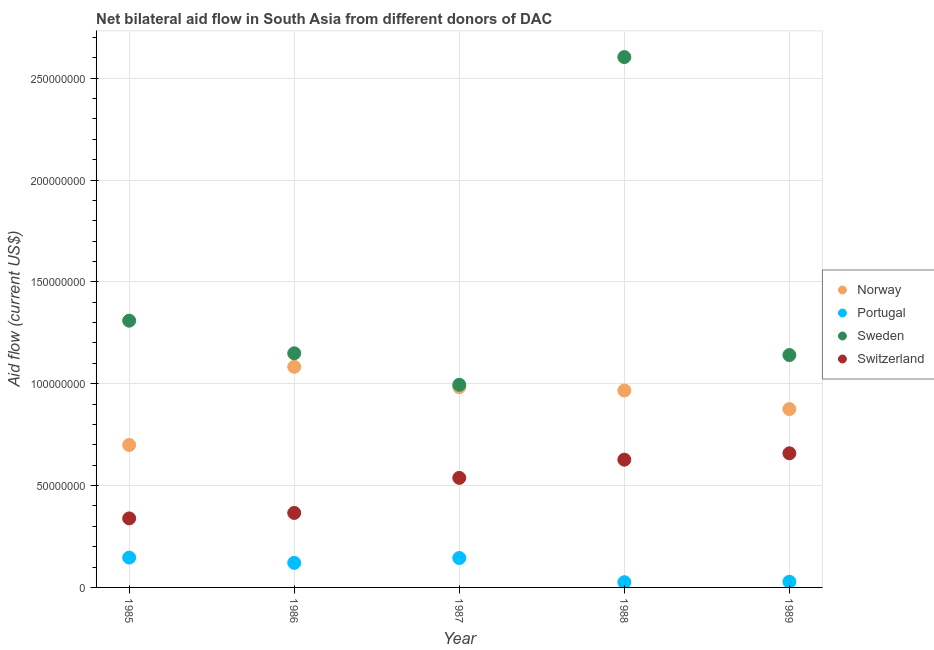Is the number of dotlines equal to the number of legend labels?
Your answer should be very brief. Yes. What is the amount of aid given by norway in 1985?
Keep it short and to the point. 6.99e+07. Across all years, what is the maximum amount of aid given by sweden?
Ensure brevity in your answer.  2.60e+08. Across all years, what is the minimum amount of aid given by sweden?
Your answer should be compact. 9.95e+07. In which year was the amount of aid given by portugal maximum?
Provide a succinct answer. 1985. What is the total amount of aid given by portugal in the graph?
Keep it short and to the point. 4.65e+07. What is the difference between the amount of aid given by sweden in 1988 and that in 1989?
Ensure brevity in your answer.  1.46e+08. What is the difference between the amount of aid given by portugal in 1989 and the amount of aid given by norway in 1987?
Keep it short and to the point. -9.55e+07. What is the average amount of aid given by switzerland per year?
Your answer should be very brief. 5.06e+07. In the year 1989, what is the difference between the amount of aid given by switzerland and amount of aid given by norway?
Offer a very short reply. -2.17e+07. In how many years, is the amount of aid given by portugal greater than 20000000 US$?
Make the answer very short. 0. What is the ratio of the amount of aid given by switzerland in 1986 to that in 1988?
Offer a terse response. 0.58. Is the amount of aid given by switzerland in 1985 less than that in 1986?
Give a very brief answer. Yes. Is the difference between the amount of aid given by norway in 1985 and 1988 greater than the difference between the amount of aid given by portugal in 1985 and 1988?
Your answer should be compact. No. What is the difference between the highest and the second highest amount of aid given by switzerland?
Offer a very short reply. 3.14e+06. What is the difference between the highest and the lowest amount of aid given by switzerland?
Keep it short and to the point. 3.20e+07. In how many years, is the amount of aid given by portugal greater than the average amount of aid given by portugal taken over all years?
Your response must be concise. 3. Is it the case that in every year, the sum of the amount of aid given by norway and amount of aid given by portugal is greater than the amount of aid given by sweden?
Provide a short and direct response. No. Does the amount of aid given by sweden monotonically increase over the years?
Keep it short and to the point. No. Is the amount of aid given by norway strictly less than the amount of aid given by sweden over the years?
Keep it short and to the point. Yes. How many dotlines are there?
Provide a succinct answer. 4. How many years are there in the graph?
Keep it short and to the point. 5. What is the difference between two consecutive major ticks on the Y-axis?
Your response must be concise. 5.00e+07. How many legend labels are there?
Keep it short and to the point. 4. What is the title of the graph?
Offer a very short reply. Net bilateral aid flow in South Asia from different donors of DAC. What is the label or title of the X-axis?
Offer a very short reply. Year. What is the label or title of the Y-axis?
Keep it short and to the point. Aid flow (current US$). What is the Aid flow (current US$) of Norway in 1985?
Ensure brevity in your answer.  6.99e+07. What is the Aid flow (current US$) in Portugal in 1985?
Give a very brief answer. 1.46e+07. What is the Aid flow (current US$) of Sweden in 1985?
Provide a succinct answer. 1.31e+08. What is the Aid flow (current US$) in Switzerland in 1985?
Your answer should be very brief. 3.39e+07. What is the Aid flow (current US$) of Norway in 1986?
Your answer should be very brief. 1.08e+08. What is the Aid flow (current US$) of Portugal in 1986?
Ensure brevity in your answer.  1.21e+07. What is the Aid flow (current US$) in Sweden in 1986?
Make the answer very short. 1.15e+08. What is the Aid flow (current US$) of Switzerland in 1986?
Keep it short and to the point. 3.66e+07. What is the Aid flow (current US$) in Norway in 1987?
Make the answer very short. 9.83e+07. What is the Aid flow (current US$) in Portugal in 1987?
Offer a terse response. 1.44e+07. What is the Aid flow (current US$) in Sweden in 1987?
Keep it short and to the point. 9.95e+07. What is the Aid flow (current US$) of Switzerland in 1987?
Your answer should be very brief. 5.38e+07. What is the Aid flow (current US$) of Norway in 1988?
Your response must be concise. 9.67e+07. What is the Aid flow (current US$) in Portugal in 1988?
Your answer should be very brief. 2.56e+06. What is the Aid flow (current US$) in Sweden in 1988?
Provide a succinct answer. 2.60e+08. What is the Aid flow (current US$) of Switzerland in 1988?
Your answer should be compact. 6.27e+07. What is the Aid flow (current US$) in Norway in 1989?
Make the answer very short. 8.76e+07. What is the Aid flow (current US$) in Portugal in 1989?
Ensure brevity in your answer.  2.79e+06. What is the Aid flow (current US$) in Sweden in 1989?
Give a very brief answer. 1.14e+08. What is the Aid flow (current US$) in Switzerland in 1989?
Make the answer very short. 6.58e+07. Across all years, what is the maximum Aid flow (current US$) in Norway?
Your answer should be compact. 1.08e+08. Across all years, what is the maximum Aid flow (current US$) in Portugal?
Your answer should be very brief. 1.46e+07. Across all years, what is the maximum Aid flow (current US$) of Sweden?
Ensure brevity in your answer.  2.60e+08. Across all years, what is the maximum Aid flow (current US$) of Switzerland?
Provide a succinct answer. 6.58e+07. Across all years, what is the minimum Aid flow (current US$) in Norway?
Keep it short and to the point. 6.99e+07. Across all years, what is the minimum Aid flow (current US$) in Portugal?
Provide a short and direct response. 2.56e+06. Across all years, what is the minimum Aid flow (current US$) in Sweden?
Offer a very short reply. 9.95e+07. Across all years, what is the minimum Aid flow (current US$) of Switzerland?
Ensure brevity in your answer.  3.39e+07. What is the total Aid flow (current US$) in Norway in the graph?
Offer a very short reply. 4.61e+08. What is the total Aid flow (current US$) of Portugal in the graph?
Provide a short and direct response. 4.65e+07. What is the total Aid flow (current US$) of Sweden in the graph?
Your response must be concise. 7.20e+08. What is the total Aid flow (current US$) in Switzerland in the graph?
Keep it short and to the point. 2.53e+08. What is the difference between the Aid flow (current US$) of Norway in 1985 and that in 1986?
Offer a terse response. -3.84e+07. What is the difference between the Aid flow (current US$) in Portugal in 1985 and that in 1986?
Your answer should be very brief. 2.59e+06. What is the difference between the Aid flow (current US$) in Sweden in 1985 and that in 1986?
Keep it short and to the point. 1.60e+07. What is the difference between the Aid flow (current US$) in Switzerland in 1985 and that in 1986?
Provide a short and direct response. -2.68e+06. What is the difference between the Aid flow (current US$) of Norway in 1985 and that in 1987?
Keep it short and to the point. -2.84e+07. What is the difference between the Aid flow (current US$) of Portugal in 1985 and that in 1987?
Offer a very short reply. 2.10e+05. What is the difference between the Aid flow (current US$) in Sweden in 1985 and that in 1987?
Provide a short and direct response. 3.15e+07. What is the difference between the Aid flow (current US$) in Switzerland in 1985 and that in 1987?
Provide a succinct answer. -1.99e+07. What is the difference between the Aid flow (current US$) in Norway in 1985 and that in 1988?
Your answer should be compact. -2.67e+07. What is the difference between the Aid flow (current US$) in Portugal in 1985 and that in 1988?
Ensure brevity in your answer.  1.21e+07. What is the difference between the Aid flow (current US$) of Sweden in 1985 and that in 1988?
Your answer should be very brief. -1.29e+08. What is the difference between the Aid flow (current US$) of Switzerland in 1985 and that in 1988?
Keep it short and to the point. -2.88e+07. What is the difference between the Aid flow (current US$) in Norway in 1985 and that in 1989?
Keep it short and to the point. -1.76e+07. What is the difference between the Aid flow (current US$) in Portugal in 1985 and that in 1989?
Offer a terse response. 1.19e+07. What is the difference between the Aid flow (current US$) in Sweden in 1985 and that in 1989?
Your answer should be very brief. 1.69e+07. What is the difference between the Aid flow (current US$) of Switzerland in 1985 and that in 1989?
Provide a succinct answer. -3.20e+07. What is the difference between the Aid flow (current US$) in Portugal in 1986 and that in 1987?
Make the answer very short. -2.38e+06. What is the difference between the Aid flow (current US$) of Sweden in 1986 and that in 1987?
Ensure brevity in your answer.  1.55e+07. What is the difference between the Aid flow (current US$) of Switzerland in 1986 and that in 1987?
Your answer should be compact. -1.72e+07. What is the difference between the Aid flow (current US$) in Norway in 1986 and that in 1988?
Your answer should be very brief. 1.16e+07. What is the difference between the Aid flow (current US$) in Portugal in 1986 and that in 1988?
Your answer should be compact. 9.50e+06. What is the difference between the Aid flow (current US$) in Sweden in 1986 and that in 1988?
Offer a very short reply. -1.45e+08. What is the difference between the Aid flow (current US$) of Switzerland in 1986 and that in 1988?
Offer a very short reply. -2.61e+07. What is the difference between the Aid flow (current US$) in Norway in 1986 and that in 1989?
Your answer should be very brief. 2.08e+07. What is the difference between the Aid flow (current US$) of Portugal in 1986 and that in 1989?
Offer a very short reply. 9.27e+06. What is the difference between the Aid flow (current US$) of Sweden in 1986 and that in 1989?
Offer a very short reply. 8.70e+05. What is the difference between the Aid flow (current US$) of Switzerland in 1986 and that in 1989?
Make the answer very short. -2.93e+07. What is the difference between the Aid flow (current US$) in Norway in 1987 and that in 1988?
Provide a short and direct response. 1.65e+06. What is the difference between the Aid flow (current US$) of Portugal in 1987 and that in 1988?
Offer a very short reply. 1.19e+07. What is the difference between the Aid flow (current US$) in Sweden in 1987 and that in 1988?
Give a very brief answer. -1.61e+08. What is the difference between the Aid flow (current US$) of Switzerland in 1987 and that in 1988?
Offer a terse response. -8.93e+06. What is the difference between the Aid flow (current US$) in Norway in 1987 and that in 1989?
Your answer should be very brief. 1.08e+07. What is the difference between the Aid flow (current US$) in Portugal in 1987 and that in 1989?
Your answer should be compact. 1.16e+07. What is the difference between the Aid flow (current US$) of Sweden in 1987 and that in 1989?
Your answer should be very brief. -1.46e+07. What is the difference between the Aid flow (current US$) in Switzerland in 1987 and that in 1989?
Offer a very short reply. -1.21e+07. What is the difference between the Aid flow (current US$) in Norway in 1988 and that in 1989?
Keep it short and to the point. 9.12e+06. What is the difference between the Aid flow (current US$) in Portugal in 1988 and that in 1989?
Your answer should be compact. -2.30e+05. What is the difference between the Aid flow (current US$) of Sweden in 1988 and that in 1989?
Offer a terse response. 1.46e+08. What is the difference between the Aid flow (current US$) in Switzerland in 1988 and that in 1989?
Offer a very short reply. -3.14e+06. What is the difference between the Aid flow (current US$) in Norway in 1985 and the Aid flow (current US$) in Portugal in 1986?
Provide a short and direct response. 5.79e+07. What is the difference between the Aid flow (current US$) in Norway in 1985 and the Aid flow (current US$) in Sweden in 1986?
Keep it short and to the point. -4.50e+07. What is the difference between the Aid flow (current US$) in Norway in 1985 and the Aid flow (current US$) in Switzerland in 1986?
Offer a very short reply. 3.34e+07. What is the difference between the Aid flow (current US$) of Portugal in 1985 and the Aid flow (current US$) of Sweden in 1986?
Make the answer very short. -1.00e+08. What is the difference between the Aid flow (current US$) in Portugal in 1985 and the Aid flow (current US$) in Switzerland in 1986?
Offer a very short reply. -2.19e+07. What is the difference between the Aid flow (current US$) in Sweden in 1985 and the Aid flow (current US$) in Switzerland in 1986?
Your answer should be very brief. 9.44e+07. What is the difference between the Aid flow (current US$) in Norway in 1985 and the Aid flow (current US$) in Portugal in 1987?
Your answer should be compact. 5.55e+07. What is the difference between the Aid flow (current US$) of Norway in 1985 and the Aid flow (current US$) of Sweden in 1987?
Make the answer very short. -2.96e+07. What is the difference between the Aid flow (current US$) of Norway in 1985 and the Aid flow (current US$) of Switzerland in 1987?
Your answer should be compact. 1.62e+07. What is the difference between the Aid flow (current US$) in Portugal in 1985 and the Aid flow (current US$) in Sweden in 1987?
Your response must be concise. -8.48e+07. What is the difference between the Aid flow (current US$) in Portugal in 1985 and the Aid flow (current US$) in Switzerland in 1987?
Provide a short and direct response. -3.91e+07. What is the difference between the Aid flow (current US$) of Sweden in 1985 and the Aid flow (current US$) of Switzerland in 1987?
Your answer should be compact. 7.72e+07. What is the difference between the Aid flow (current US$) of Norway in 1985 and the Aid flow (current US$) of Portugal in 1988?
Keep it short and to the point. 6.74e+07. What is the difference between the Aid flow (current US$) of Norway in 1985 and the Aid flow (current US$) of Sweden in 1988?
Ensure brevity in your answer.  -1.90e+08. What is the difference between the Aid flow (current US$) of Norway in 1985 and the Aid flow (current US$) of Switzerland in 1988?
Provide a short and direct response. 7.22e+06. What is the difference between the Aid flow (current US$) of Portugal in 1985 and the Aid flow (current US$) of Sweden in 1988?
Give a very brief answer. -2.46e+08. What is the difference between the Aid flow (current US$) of Portugal in 1985 and the Aid flow (current US$) of Switzerland in 1988?
Make the answer very short. -4.81e+07. What is the difference between the Aid flow (current US$) of Sweden in 1985 and the Aid flow (current US$) of Switzerland in 1988?
Your response must be concise. 6.82e+07. What is the difference between the Aid flow (current US$) of Norway in 1985 and the Aid flow (current US$) of Portugal in 1989?
Ensure brevity in your answer.  6.71e+07. What is the difference between the Aid flow (current US$) in Norway in 1985 and the Aid flow (current US$) in Sweden in 1989?
Give a very brief answer. -4.42e+07. What is the difference between the Aid flow (current US$) of Norway in 1985 and the Aid flow (current US$) of Switzerland in 1989?
Your answer should be compact. 4.08e+06. What is the difference between the Aid flow (current US$) of Portugal in 1985 and the Aid flow (current US$) of Sweden in 1989?
Provide a short and direct response. -9.94e+07. What is the difference between the Aid flow (current US$) of Portugal in 1985 and the Aid flow (current US$) of Switzerland in 1989?
Ensure brevity in your answer.  -5.12e+07. What is the difference between the Aid flow (current US$) in Sweden in 1985 and the Aid flow (current US$) in Switzerland in 1989?
Give a very brief answer. 6.51e+07. What is the difference between the Aid flow (current US$) of Norway in 1986 and the Aid flow (current US$) of Portugal in 1987?
Your response must be concise. 9.39e+07. What is the difference between the Aid flow (current US$) of Norway in 1986 and the Aid flow (current US$) of Sweden in 1987?
Your response must be concise. 8.83e+06. What is the difference between the Aid flow (current US$) in Norway in 1986 and the Aid flow (current US$) in Switzerland in 1987?
Your answer should be compact. 5.45e+07. What is the difference between the Aid flow (current US$) of Portugal in 1986 and the Aid flow (current US$) of Sweden in 1987?
Keep it short and to the point. -8.74e+07. What is the difference between the Aid flow (current US$) of Portugal in 1986 and the Aid flow (current US$) of Switzerland in 1987?
Ensure brevity in your answer.  -4.17e+07. What is the difference between the Aid flow (current US$) in Sweden in 1986 and the Aid flow (current US$) in Switzerland in 1987?
Keep it short and to the point. 6.12e+07. What is the difference between the Aid flow (current US$) of Norway in 1986 and the Aid flow (current US$) of Portugal in 1988?
Your response must be concise. 1.06e+08. What is the difference between the Aid flow (current US$) of Norway in 1986 and the Aid flow (current US$) of Sweden in 1988?
Offer a very short reply. -1.52e+08. What is the difference between the Aid flow (current US$) of Norway in 1986 and the Aid flow (current US$) of Switzerland in 1988?
Your answer should be very brief. 4.56e+07. What is the difference between the Aid flow (current US$) in Portugal in 1986 and the Aid flow (current US$) in Sweden in 1988?
Keep it short and to the point. -2.48e+08. What is the difference between the Aid flow (current US$) of Portugal in 1986 and the Aid flow (current US$) of Switzerland in 1988?
Offer a terse response. -5.06e+07. What is the difference between the Aid flow (current US$) of Sweden in 1986 and the Aid flow (current US$) of Switzerland in 1988?
Your response must be concise. 5.22e+07. What is the difference between the Aid flow (current US$) of Norway in 1986 and the Aid flow (current US$) of Portugal in 1989?
Offer a terse response. 1.06e+08. What is the difference between the Aid flow (current US$) of Norway in 1986 and the Aid flow (current US$) of Sweden in 1989?
Provide a short and direct response. -5.76e+06. What is the difference between the Aid flow (current US$) in Norway in 1986 and the Aid flow (current US$) in Switzerland in 1989?
Ensure brevity in your answer.  4.25e+07. What is the difference between the Aid flow (current US$) of Portugal in 1986 and the Aid flow (current US$) of Sweden in 1989?
Make the answer very short. -1.02e+08. What is the difference between the Aid flow (current US$) of Portugal in 1986 and the Aid flow (current US$) of Switzerland in 1989?
Your answer should be compact. -5.38e+07. What is the difference between the Aid flow (current US$) of Sweden in 1986 and the Aid flow (current US$) of Switzerland in 1989?
Your response must be concise. 4.91e+07. What is the difference between the Aid flow (current US$) in Norway in 1987 and the Aid flow (current US$) in Portugal in 1988?
Your answer should be very brief. 9.58e+07. What is the difference between the Aid flow (current US$) in Norway in 1987 and the Aid flow (current US$) in Sweden in 1988?
Give a very brief answer. -1.62e+08. What is the difference between the Aid flow (current US$) of Norway in 1987 and the Aid flow (current US$) of Switzerland in 1988?
Your response must be concise. 3.56e+07. What is the difference between the Aid flow (current US$) of Portugal in 1987 and the Aid flow (current US$) of Sweden in 1988?
Make the answer very short. -2.46e+08. What is the difference between the Aid flow (current US$) of Portugal in 1987 and the Aid flow (current US$) of Switzerland in 1988?
Keep it short and to the point. -4.83e+07. What is the difference between the Aid flow (current US$) of Sweden in 1987 and the Aid flow (current US$) of Switzerland in 1988?
Your answer should be compact. 3.68e+07. What is the difference between the Aid flow (current US$) in Norway in 1987 and the Aid flow (current US$) in Portugal in 1989?
Keep it short and to the point. 9.55e+07. What is the difference between the Aid flow (current US$) of Norway in 1987 and the Aid flow (current US$) of Sweden in 1989?
Make the answer very short. -1.58e+07. What is the difference between the Aid flow (current US$) in Norway in 1987 and the Aid flow (current US$) in Switzerland in 1989?
Give a very brief answer. 3.25e+07. What is the difference between the Aid flow (current US$) in Portugal in 1987 and the Aid flow (current US$) in Sweden in 1989?
Your response must be concise. -9.96e+07. What is the difference between the Aid flow (current US$) in Portugal in 1987 and the Aid flow (current US$) in Switzerland in 1989?
Ensure brevity in your answer.  -5.14e+07. What is the difference between the Aid flow (current US$) in Sweden in 1987 and the Aid flow (current US$) in Switzerland in 1989?
Keep it short and to the point. 3.36e+07. What is the difference between the Aid flow (current US$) in Norway in 1988 and the Aid flow (current US$) in Portugal in 1989?
Your response must be concise. 9.39e+07. What is the difference between the Aid flow (current US$) in Norway in 1988 and the Aid flow (current US$) in Sweden in 1989?
Offer a terse response. -1.74e+07. What is the difference between the Aid flow (current US$) in Norway in 1988 and the Aid flow (current US$) in Switzerland in 1989?
Your response must be concise. 3.08e+07. What is the difference between the Aid flow (current US$) in Portugal in 1988 and the Aid flow (current US$) in Sweden in 1989?
Provide a succinct answer. -1.12e+08. What is the difference between the Aid flow (current US$) of Portugal in 1988 and the Aid flow (current US$) of Switzerland in 1989?
Your answer should be compact. -6.33e+07. What is the difference between the Aid flow (current US$) of Sweden in 1988 and the Aid flow (current US$) of Switzerland in 1989?
Provide a succinct answer. 1.95e+08. What is the average Aid flow (current US$) in Norway per year?
Your answer should be very brief. 9.22e+07. What is the average Aid flow (current US$) in Portugal per year?
Your answer should be very brief. 9.30e+06. What is the average Aid flow (current US$) in Sweden per year?
Give a very brief answer. 1.44e+08. What is the average Aid flow (current US$) in Switzerland per year?
Your response must be concise. 5.06e+07. In the year 1985, what is the difference between the Aid flow (current US$) in Norway and Aid flow (current US$) in Portugal?
Keep it short and to the point. 5.53e+07. In the year 1985, what is the difference between the Aid flow (current US$) in Norway and Aid flow (current US$) in Sweden?
Give a very brief answer. -6.10e+07. In the year 1985, what is the difference between the Aid flow (current US$) of Norway and Aid flow (current US$) of Switzerland?
Keep it short and to the point. 3.60e+07. In the year 1985, what is the difference between the Aid flow (current US$) of Portugal and Aid flow (current US$) of Sweden?
Offer a terse response. -1.16e+08. In the year 1985, what is the difference between the Aid flow (current US$) of Portugal and Aid flow (current US$) of Switzerland?
Your response must be concise. -1.92e+07. In the year 1985, what is the difference between the Aid flow (current US$) of Sweden and Aid flow (current US$) of Switzerland?
Give a very brief answer. 9.71e+07. In the year 1986, what is the difference between the Aid flow (current US$) of Norway and Aid flow (current US$) of Portugal?
Your response must be concise. 9.63e+07. In the year 1986, what is the difference between the Aid flow (current US$) in Norway and Aid flow (current US$) in Sweden?
Offer a very short reply. -6.63e+06. In the year 1986, what is the difference between the Aid flow (current US$) in Norway and Aid flow (current US$) in Switzerland?
Provide a short and direct response. 7.18e+07. In the year 1986, what is the difference between the Aid flow (current US$) in Portugal and Aid flow (current US$) in Sweden?
Ensure brevity in your answer.  -1.03e+08. In the year 1986, what is the difference between the Aid flow (current US$) of Portugal and Aid flow (current US$) of Switzerland?
Provide a short and direct response. -2.45e+07. In the year 1986, what is the difference between the Aid flow (current US$) in Sweden and Aid flow (current US$) in Switzerland?
Provide a short and direct response. 7.84e+07. In the year 1987, what is the difference between the Aid flow (current US$) in Norway and Aid flow (current US$) in Portugal?
Offer a terse response. 8.39e+07. In the year 1987, what is the difference between the Aid flow (current US$) of Norway and Aid flow (current US$) of Sweden?
Your response must be concise. -1.17e+06. In the year 1987, what is the difference between the Aid flow (current US$) in Norway and Aid flow (current US$) in Switzerland?
Offer a very short reply. 4.45e+07. In the year 1987, what is the difference between the Aid flow (current US$) in Portugal and Aid flow (current US$) in Sweden?
Keep it short and to the point. -8.50e+07. In the year 1987, what is the difference between the Aid flow (current US$) in Portugal and Aid flow (current US$) in Switzerland?
Your response must be concise. -3.93e+07. In the year 1987, what is the difference between the Aid flow (current US$) in Sweden and Aid flow (current US$) in Switzerland?
Make the answer very short. 4.57e+07. In the year 1988, what is the difference between the Aid flow (current US$) in Norway and Aid flow (current US$) in Portugal?
Your answer should be compact. 9.41e+07. In the year 1988, what is the difference between the Aid flow (current US$) in Norway and Aid flow (current US$) in Sweden?
Make the answer very short. -1.64e+08. In the year 1988, what is the difference between the Aid flow (current US$) in Norway and Aid flow (current US$) in Switzerland?
Offer a very short reply. 3.40e+07. In the year 1988, what is the difference between the Aid flow (current US$) in Portugal and Aid flow (current US$) in Sweden?
Give a very brief answer. -2.58e+08. In the year 1988, what is the difference between the Aid flow (current US$) in Portugal and Aid flow (current US$) in Switzerland?
Make the answer very short. -6.02e+07. In the year 1988, what is the difference between the Aid flow (current US$) of Sweden and Aid flow (current US$) of Switzerland?
Offer a terse response. 1.98e+08. In the year 1989, what is the difference between the Aid flow (current US$) in Norway and Aid flow (current US$) in Portugal?
Offer a very short reply. 8.48e+07. In the year 1989, what is the difference between the Aid flow (current US$) in Norway and Aid flow (current US$) in Sweden?
Offer a terse response. -2.65e+07. In the year 1989, what is the difference between the Aid flow (current US$) in Norway and Aid flow (current US$) in Switzerland?
Offer a terse response. 2.17e+07. In the year 1989, what is the difference between the Aid flow (current US$) in Portugal and Aid flow (current US$) in Sweden?
Your response must be concise. -1.11e+08. In the year 1989, what is the difference between the Aid flow (current US$) in Portugal and Aid flow (current US$) in Switzerland?
Keep it short and to the point. -6.31e+07. In the year 1989, what is the difference between the Aid flow (current US$) in Sweden and Aid flow (current US$) in Switzerland?
Your answer should be very brief. 4.82e+07. What is the ratio of the Aid flow (current US$) in Norway in 1985 to that in 1986?
Make the answer very short. 0.65. What is the ratio of the Aid flow (current US$) of Portugal in 1985 to that in 1986?
Your answer should be very brief. 1.21. What is the ratio of the Aid flow (current US$) of Sweden in 1985 to that in 1986?
Your answer should be compact. 1.14. What is the ratio of the Aid flow (current US$) in Switzerland in 1985 to that in 1986?
Offer a terse response. 0.93. What is the ratio of the Aid flow (current US$) of Norway in 1985 to that in 1987?
Ensure brevity in your answer.  0.71. What is the ratio of the Aid flow (current US$) in Portugal in 1985 to that in 1987?
Your answer should be very brief. 1.01. What is the ratio of the Aid flow (current US$) of Sweden in 1985 to that in 1987?
Your answer should be compact. 1.32. What is the ratio of the Aid flow (current US$) in Switzerland in 1985 to that in 1987?
Your answer should be compact. 0.63. What is the ratio of the Aid flow (current US$) in Norway in 1985 to that in 1988?
Provide a succinct answer. 0.72. What is the ratio of the Aid flow (current US$) in Portugal in 1985 to that in 1988?
Provide a succinct answer. 5.72. What is the ratio of the Aid flow (current US$) of Sweden in 1985 to that in 1988?
Your answer should be compact. 0.5. What is the ratio of the Aid flow (current US$) of Switzerland in 1985 to that in 1988?
Your response must be concise. 0.54. What is the ratio of the Aid flow (current US$) in Norway in 1985 to that in 1989?
Give a very brief answer. 0.8. What is the ratio of the Aid flow (current US$) in Portugal in 1985 to that in 1989?
Ensure brevity in your answer.  5.25. What is the ratio of the Aid flow (current US$) of Sweden in 1985 to that in 1989?
Offer a terse response. 1.15. What is the ratio of the Aid flow (current US$) in Switzerland in 1985 to that in 1989?
Provide a short and direct response. 0.51. What is the ratio of the Aid flow (current US$) in Norway in 1986 to that in 1987?
Keep it short and to the point. 1.1. What is the ratio of the Aid flow (current US$) in Portugal in 1986 to that in 1987?
Provide a succinct answer. 0.84. What is the ratio of the Aid flow (current US$) of Sweden in 1986 to that in 1987?
Give a very brief answer. 1.16. What is the ratio of the Aid flow (current US$) in Switzerland in 1986 to that in 1987?
Give a very brief answer. 0.68. What is the ratio of the Aid flow (current US$) in Norway in 1986 to that in 1988?
Your answer should be very brief. 1.12. What is the ratio of the Aid flow (current US$) in Portugal in 1986 to that in 1988?
Ensure brevity in your answer.  4.71. What is the ratio of the Aid flow (current US$) in Sweden in 1986 to that in 1988?
Your answer should be compact. 0.44. What is the ratio of the Aid flow (current US$) of Switzerland in 1986 to that in 1988?
Offer a very short reply. 0.58. What is the ratio of the Aid flow (current US$) in Norway in 1986 to that in 1989?
Keep it short and to the point. 1.24. What is the ratio of the Aid flow (current US$) of Portugal in 1986 to that in 1989?
Your response must be concise. 4.32. What is the ratio of the Aid flow (current US$) in Sweden in 1986 to that in 1989?
Ensure brevity in your answer.  1.01. What is the ratio of the Aid flow (current US$) in Switzerland in 1986 to that in 1989?
Your answer should be compact. 0.56. What is the ratio of the Aid flow (current US$) in Norway in 1987 to that in 1988?
Your answer should be very brief. 1.02. What is the ratio of the Aid flow (current US$) in Portugal in 1987 to that in 1988?
Your response must be concise. 5.64. What is the ratio of the Aid flow (current US$) in Sweden in 1987 to that in 1988?
Keep it short and to the point. 0.38. What is the ratio of the Aid flow (current US$) in Switzerland in 1987 to that in 1988?
Ensure brevity in your answer.  0.86. What is the ratio of the Aid flow (current US$) in Norway in 1987 to that in 1989?
Keep it short and to the point. 1.12. What is the ratio of the Aid flow (current US$) in Portugal in 1987 to that in 1989?
Give a very brief answer. 5.18. What is the ratio of the Aid flow (current US$) of Sweden in 1987 to that in 1989?
Your answer should be compact. 0.87. What is the ratio of the Aid flow (current US$) of Switzerland in 1987 to that in 1989?
Keep it short and to the point. 0.82. What is the ratio of the Aid flow (current US$) in Norway in 1988 to that in 1989?
Offer a very short reply. 1.1. What is the ratio of the Aid flow (current US$) in Portugal in 1988 to that in 1989?
Your answer should be very brief. 0.92. What is the ratio of the Aid flow (current US$) of Sweden in 1988 to that in 1989?
Give a very brief answer. 2.28. What is the ratio of the Aid flow (current US$) of Switzerland in 1988 to that in 1989?
Offer a very short reply. 0.95. What is the difference between the highest and the second highest Aid flow (current US$) in Norway?
Make the answer very short. 1.00e+07. What is the difference between the highest and the second highest Aid flow (current US$) in Portugal?
Offer a terse response. 2.10e+05. What is the difference between the highest and the second highest Aid flow (current US$) of Sweden?
Your response must be concise. 1.29e+08. What is the difference between the highest and the second highest Aid flow (current US$) in Switzerland?
Your answer should be compact. 3.14e+06. What is the difference between the highest and the lowest Aid flow (current US$) of Norway?
Provide a succinct answer. 3.84e+07. What is the difference between the highest and the lowest Aid flow (current US$) in Portugal?
Offer a terse response. 1.21e+07. What is the difference between the highest and the lowest Aid flow (current US$) of Sweden?
Provide a short and direct response. 1.61e+08. What is the difference between the highest and the lowest Aid flow (current US$) of Switzerland?
Provide a short and direct response. 3.20e+07. 